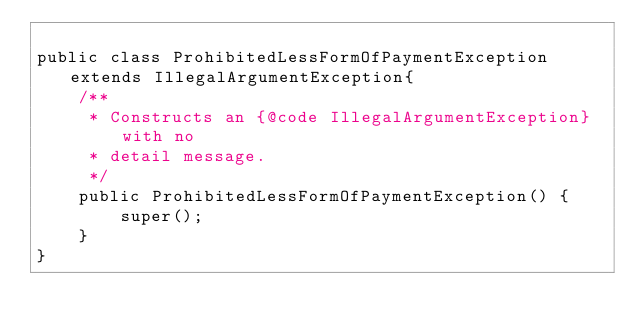Convert code to text. <code><loc_0><loc_0><loc_500><loc_500><_Java_>
public class ProhibitedLessFormOfPaymentException extends IllegalArgumentException{
    /**
     * Constructs an {@code IllegalArgumentException} with no
     * detail message.
     */
    public ProhibitedLessFormOfPaymentException() {
        super();
    }
}
</code> 